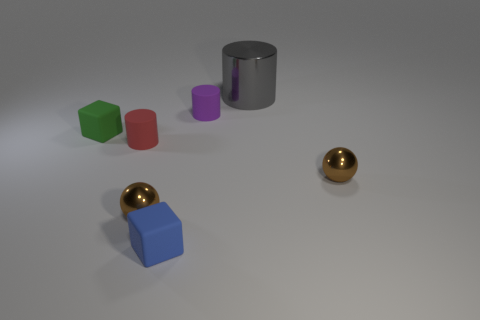Subtract all gray cylinders. How many cylinders are left? 2 Add 1 brown spheres. How many objects exist? 8 Subtract all blue blocks. Subtract all blue cylinders. How many blocks are left? 1 Subtract all tiny purple matte balls. Subtract all small things. How many objects are left? 1 Add 5 small red rubber objects. How many small red rubber objects are left? 6 Add 6 tiny brown things. How many tiny brown things exist? 8 Subtract all purple cylinders. How many cylinders are left? 2 Subtract 1 green blocks. How many objects are left? 6 Subtract all cubes. How many objects are left? 5 Subtract 1 blocks. How many blocks are left? 1 